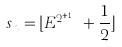<formula> <loc_0><loc_0><loc_500><loc_500>s _ { n } = \lfloor E ^ { 2 ^ { n + 1 } } + \frac { 1 } { 2 } \rfloor</formula> 